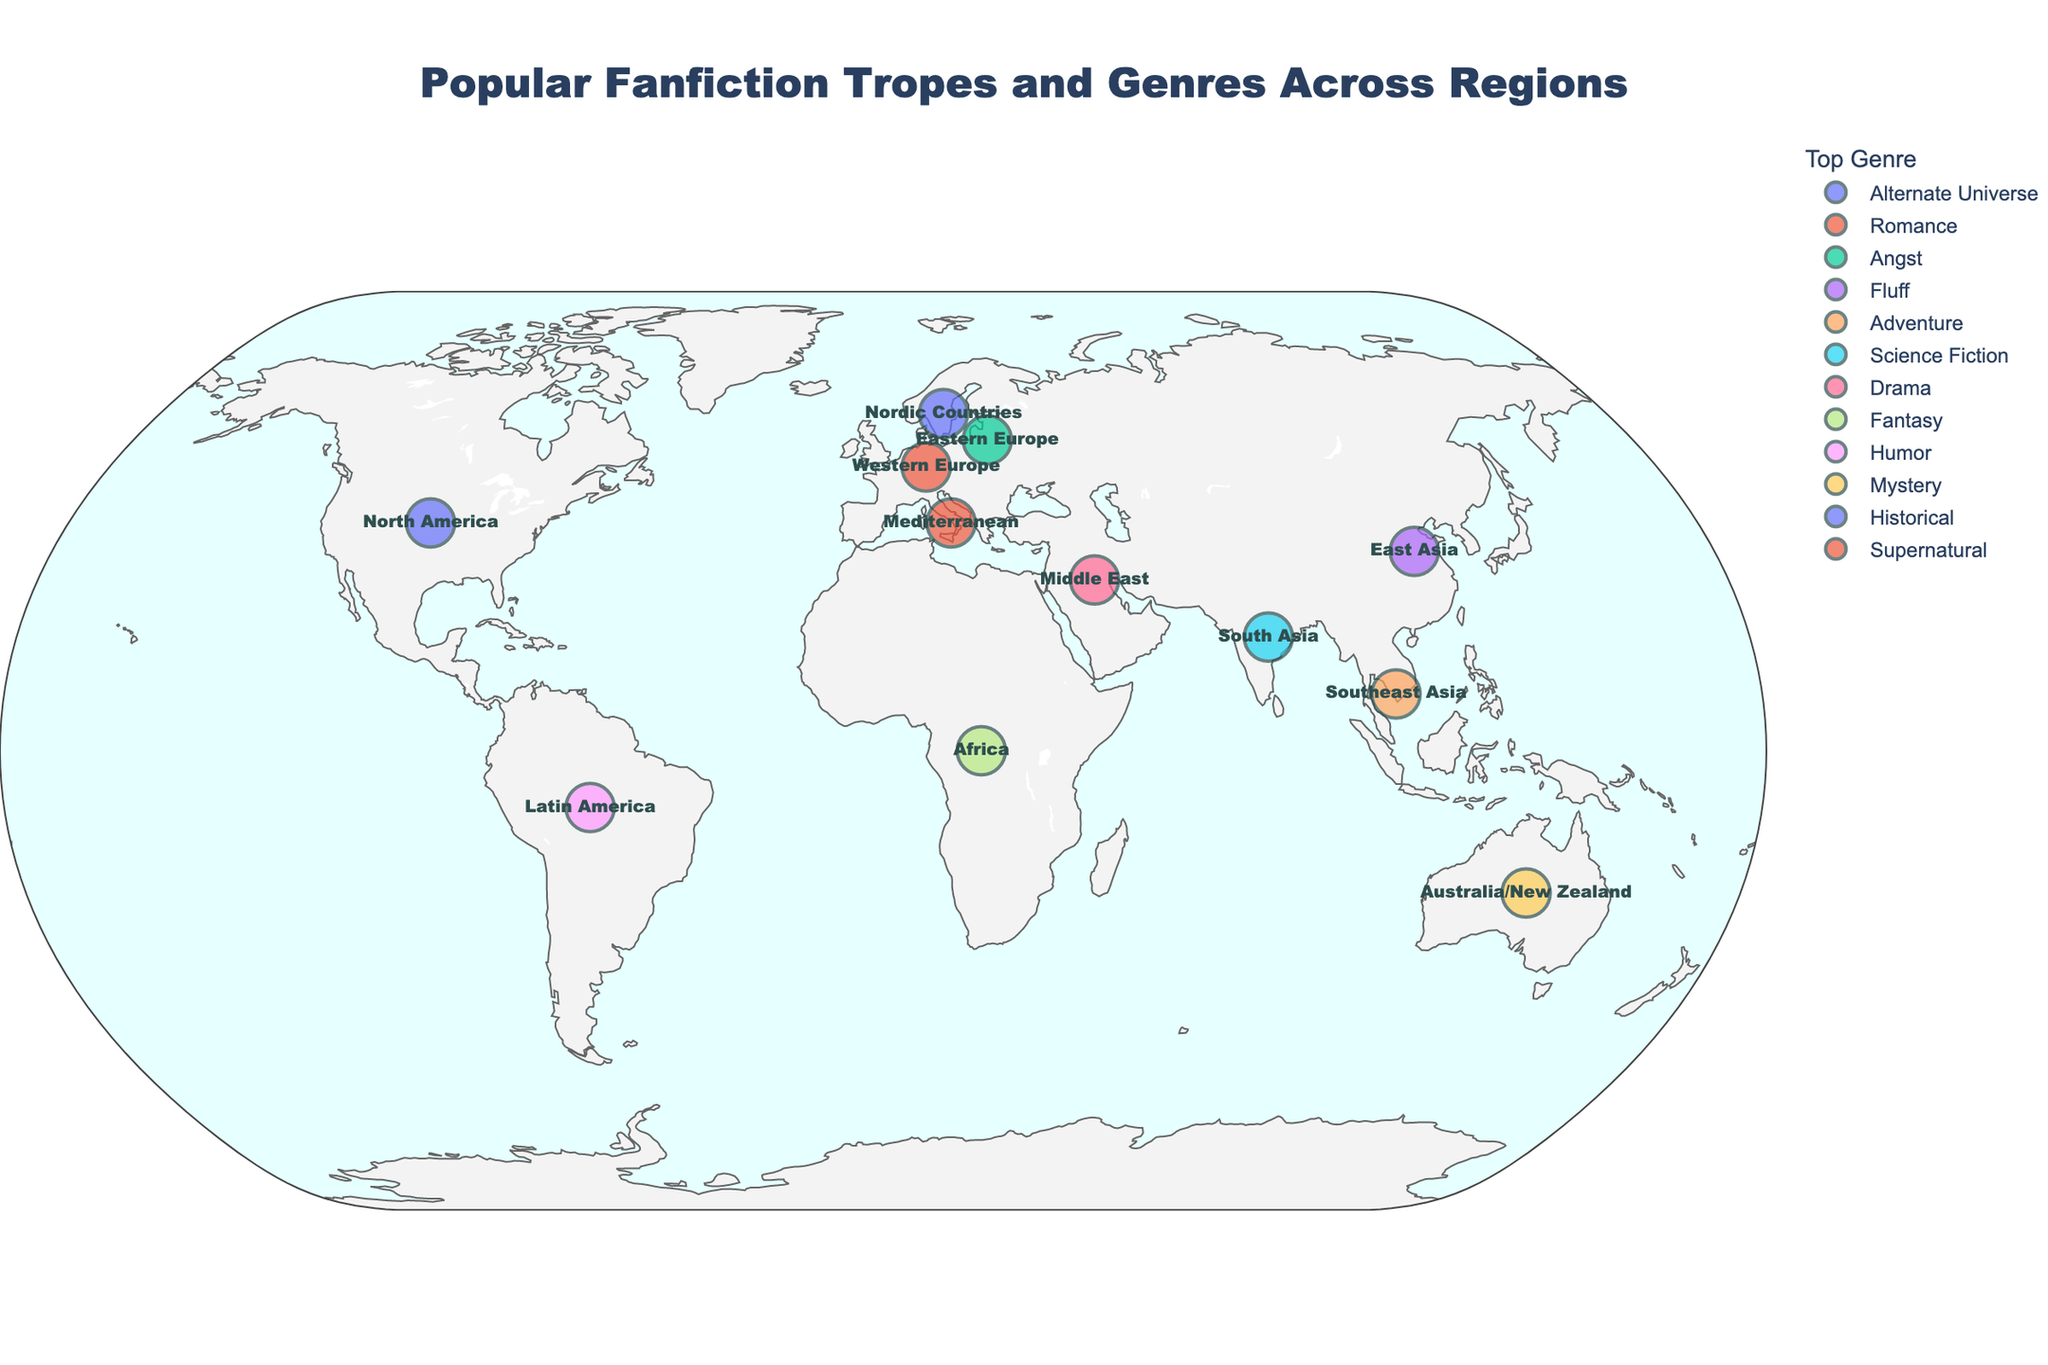How many regions are displayed in the figure? To find out how many regions are displayed, count the number of data points on the map. Each point represents a region.
Answer: 12 Which region is associated with the "Fantasy" genre? Look at the data points marked with different colors and check the hover info or legend to identify the region tagged with the "Fantasy" genre.
Answer: Africa What is the top fanfiction trope in East Asia? Hover over the East Asia point to see the detailed information displayed, which includes the top trope.
Answer: Coffee Shop AU Which region shares the "Romance" genre as its top genre? Locate the data point marked with the "Romance" genre color and hover over it to reveal the region.
Answer: Western Europe What is the most common top genre in the dataset? Compare the frequency of each genre across the regions. Count the occurrences and identify the most frequent one.
Answer: Each genre is unique (None is most common) Which regions are geographically closest to each other on the figure? Visually inspect the map to determine which plotted points are closest to each other geographically.
Answer: Northern Europe and Western Europe (Due to proximity on the map) How many regions have "Supernatural" as their top genre? Identify and count the data points tagged with "Supernatural" genre color from legend/hover info.
Answer: 1 What is the top trope for the region with coordinates approximately at (10, 105)? Find the region plotted at coordinates (10, 105) and check the hover information for its top trope.
Answer: Found Family Compare the top tropes of Mediterranean and Nordic Countries. Are they different? Hover over the Mediterranean and Nordic Countries points to see their top tropes and compare them.
Answer: Yes, they are different. Mediterranean: Second Chances; Nordic Countries: Arranged Marriage Which region has the top genre "Science Fiction"? Identify the point marked with "Science Fiction" color and reveal the region by using hover information.
Answer: South Asia 